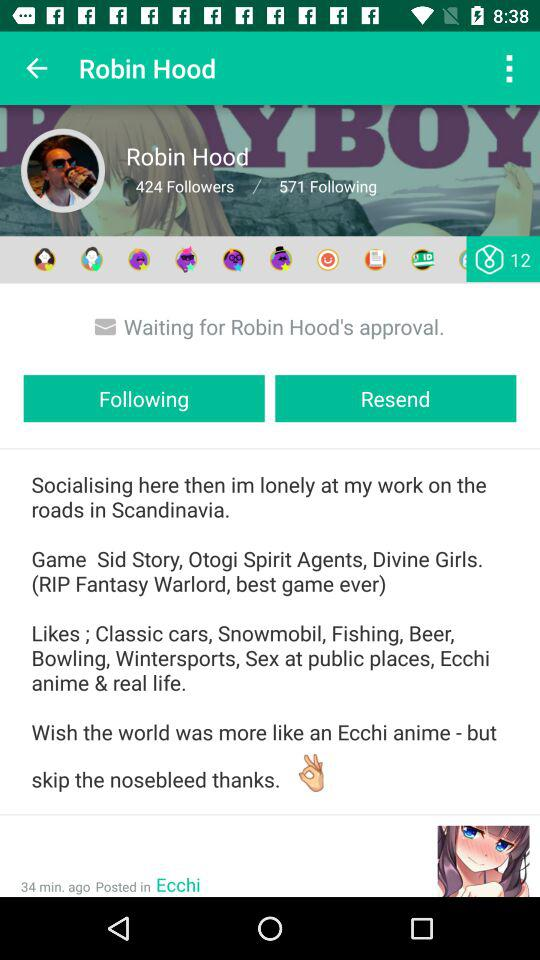How many more followings than followers does Robin Hood have?
Answer the question using a single word or phrase. 147 